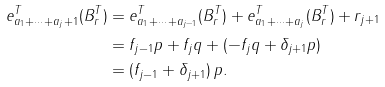Convert formula to latex. <formula><loc_0><loc_0><loc_500><loc_500>e _ { a _ { 1 } + \cdots + a _ { j } + 1 } ^ { T } ( B _ { r } ^ { T } ) & = e _ { a _ { 1 } + \cdots + a _ { j - 1 } } ^ { T } ( B _ { r } ^ { T } ) + e _ { a _ { 1 } + \cdots + a _ { j } } ^ { T } ( B _ { r } ^ { T } ) + r _ { j + 1 } \\ & = f _ { j - 1 } p + f _ { j } q + ( - f _ { j } q + \delta _ { j + 1 } p ) \\ & = ( f _ { j - 1 } + \delta _ { j + 1 } ) \, p .</formula> 